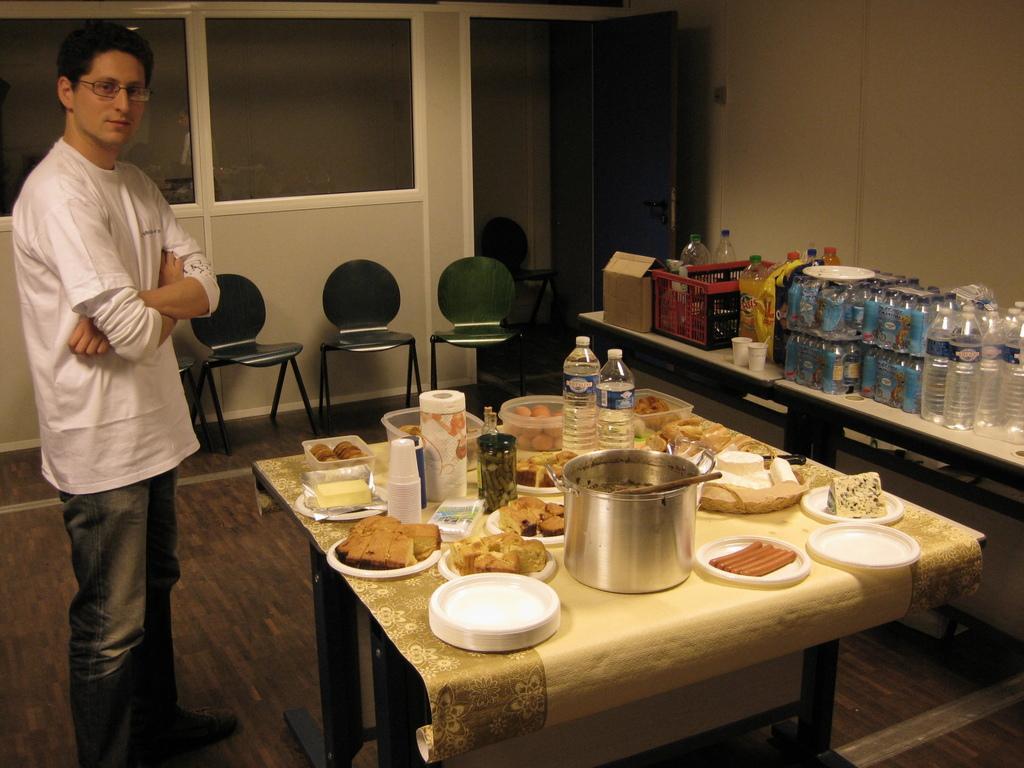In one or two sentences, can you explain what this image depicts? In the image a man is standing and smiling. Bottom of the image there is a table on the table there are some dishes and water bottles and there are some plates and cups. Top right side of the image there is a wall and door and there are some chairs. Bottom right side of the image there is a table on the table there are some water bottles and cups. 